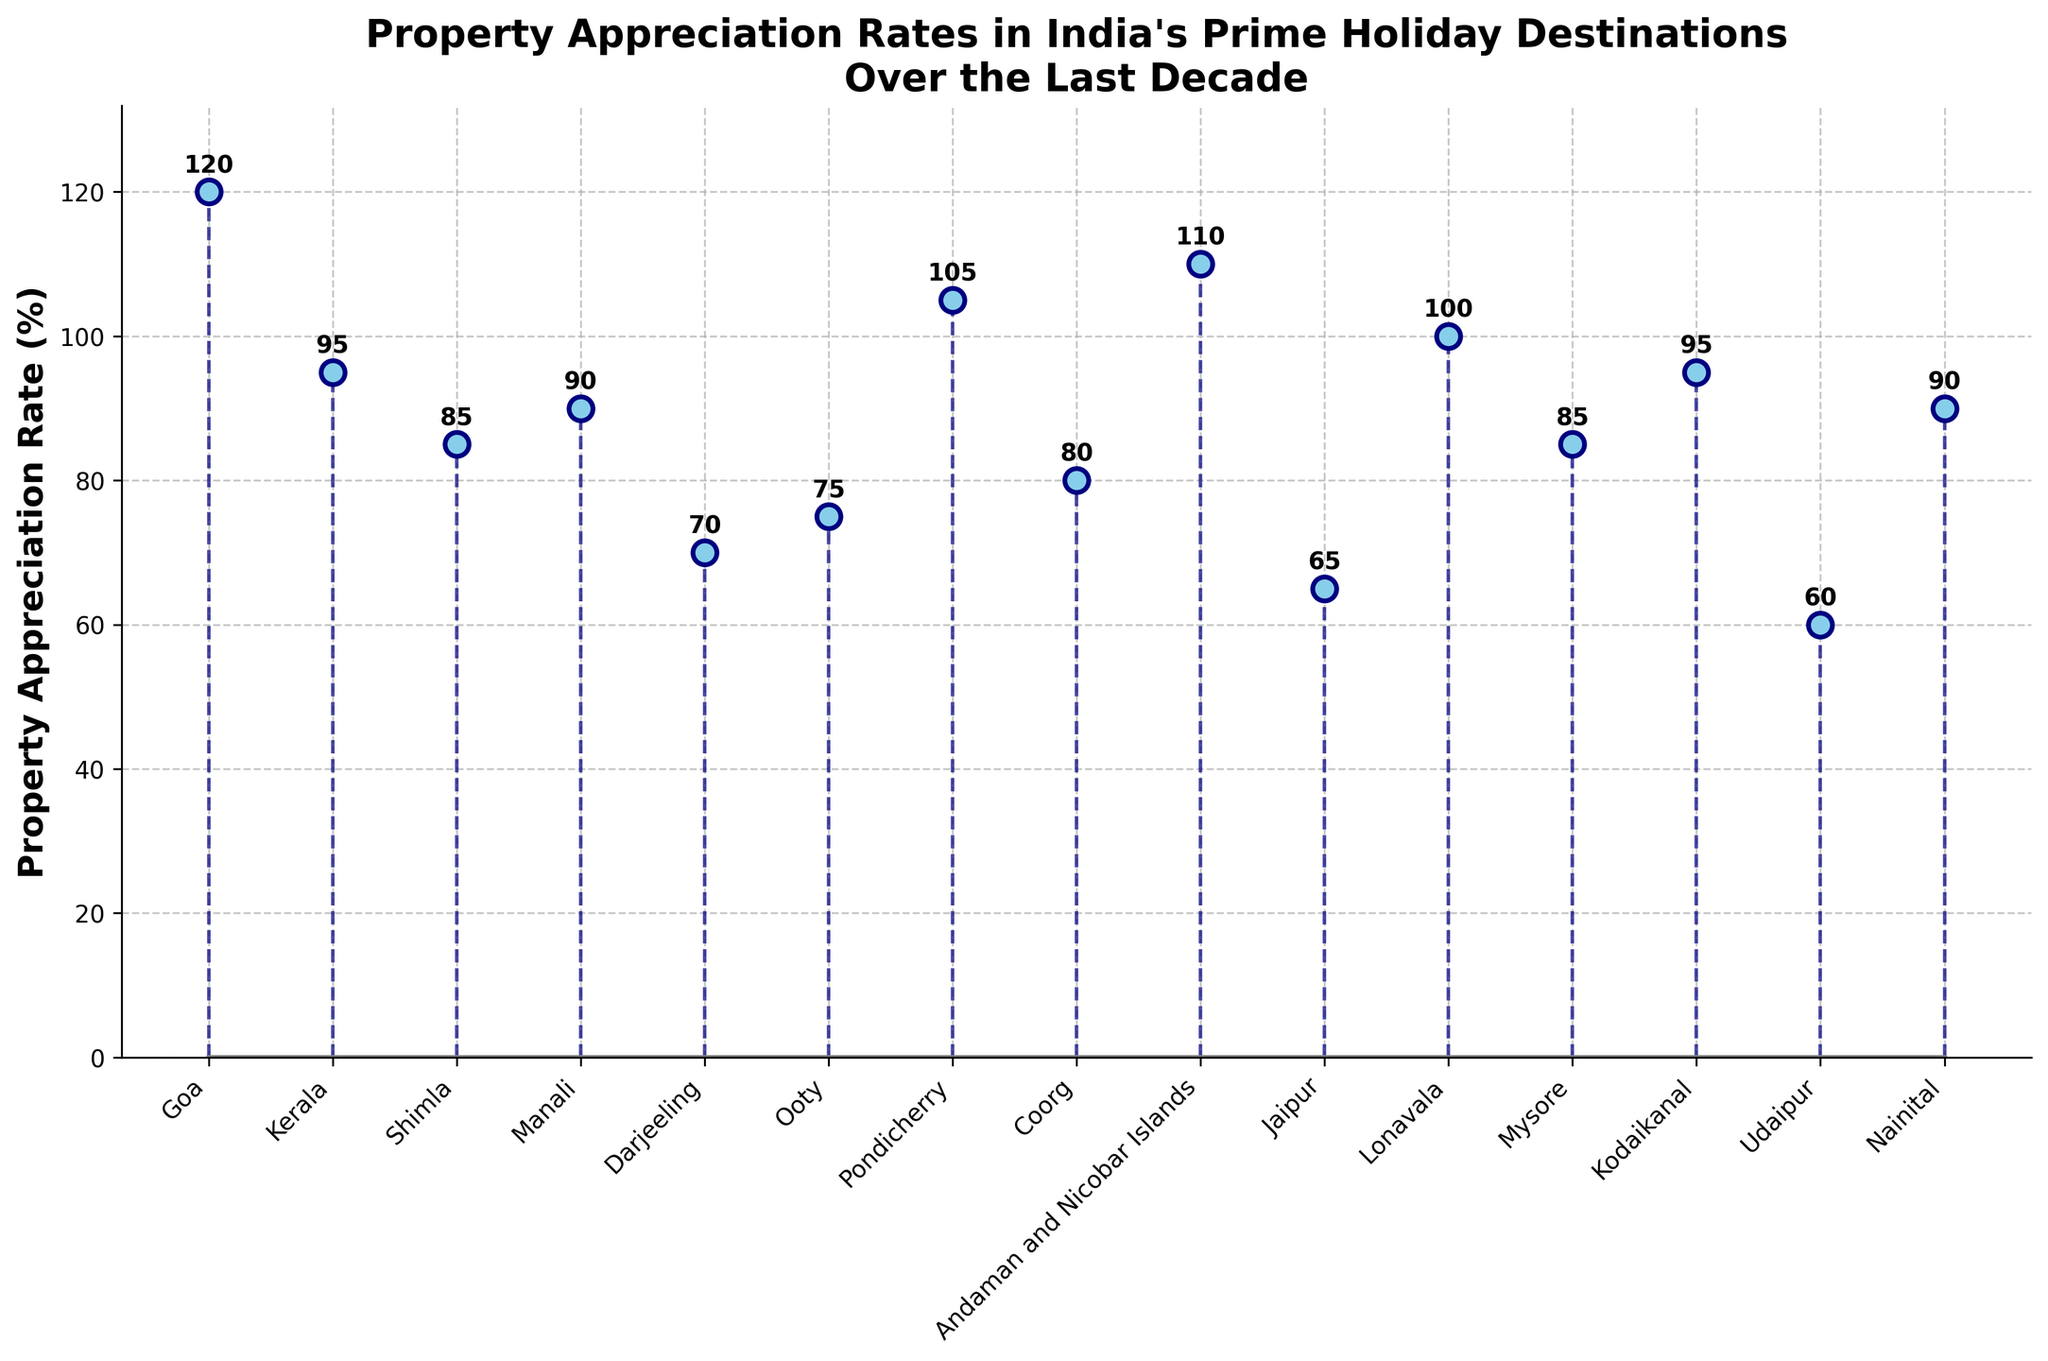What is the property appreciation rate in Goa? The stem plot shows data points for various holiday destinations. The marker for Goa is labeled with the appreciation rate.
Answer: 120% Which location has the highest property appreciation rate? From the plot, the highest point is noted as Goa, with a value of 120%.
Answer: Goa What's the difference in property appreciation rates between Udaipur and Lonavala? Udaipur has an appreciation rate of 60%, and Lonavala has 100%. Subtracting the smaller value from the larger gives 100% - 60%.
Answer: 40% What is the average property appreciation rate of all the locations shown? Sum all property appreciation rates, then divide by the number of locations: (120+95+85+90+70+75+105+80+110+65+100+85+95+60+90)/15 = 91.33
Answer: 91.33% How many locations have an appreciation rate above 100%? Reviewing the data points above the 100% line, these locations are Goa, Pondicherry, and the Andaman and Nicobar Islands (3 locations).
Answer: 3 Which location has the lowest property appreciation rate? The lowest point in the plot corresponds to Udaipur, marked at 60%.
Answer: Udaipur How does the property appreciation rate in Nainital compare to Mysore? Both Nainital and Mysore have appreciation rates as shown in the stem plot. Nainital is 90%, whereas Mysore is 85%. Nainital's rate is higher.
Answer: Nainital has a higher rate than Mysore What is the range of property appreciation rates displayed in the figure? The range is the difference between the highest (Goa, 120%) and the lowest (Udaipur, 60%) values. So, 120% - 60%.
Answer: 60% Which locations have property appreciation rates between 80% and 100%? These locations are identified from the stem plot if their markers fall between 80% and 100% lines. They are Shimla, Manali, Pondicherry, Coorg, Mysore, Kodaikanal, and Lonavala.
Answer: Shimla, Manali, Coorg, Mysore, Kodaikanal, Lonavala Is the property appreciation rate in Kerala higher than that in Shimla? Comparing the markers directly, Kerala is at 95% while Shimla is at 85%. Hence, Kerala's rate is higher.
Answer: Yes 